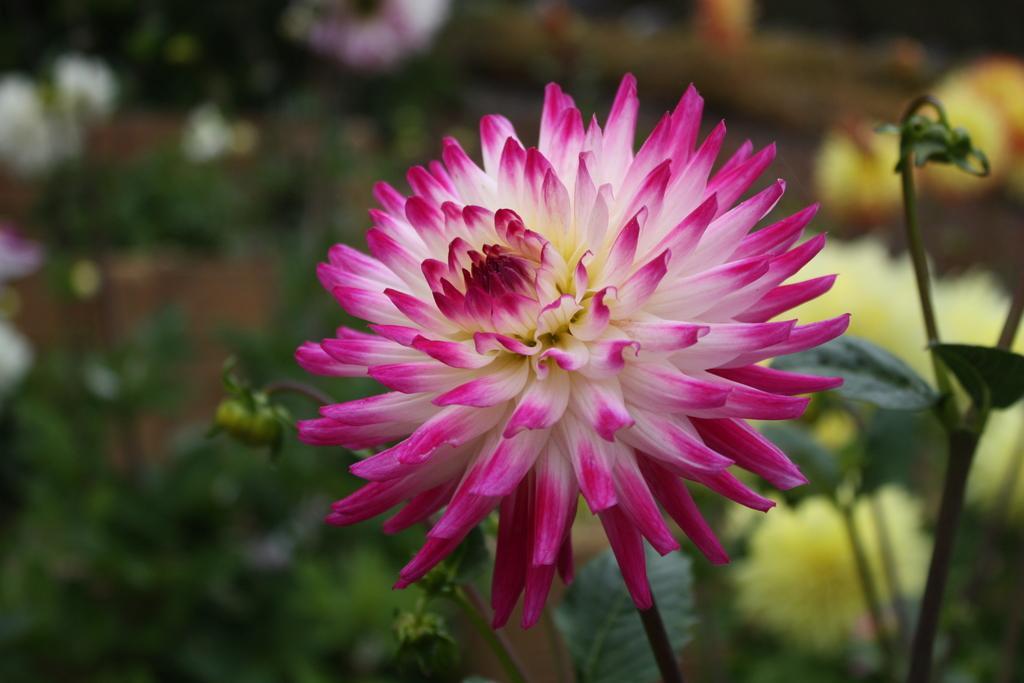Describe this image in one or two sentences. In this image I can see a flower which is in white and pink color. Background there are few plants having few flowers, buds and leaves to it. 